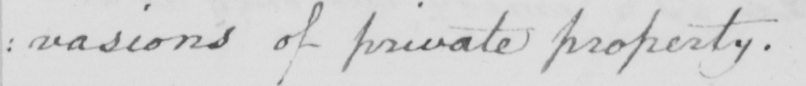What is written in this line of handwriting? : vasions of private property . 